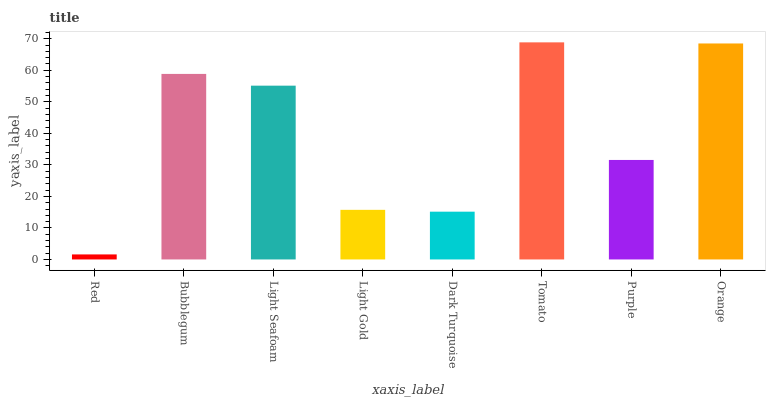Is Bubblegum the minimum?
Answer yes or no. No. Is Bubblegum the maximum?
Answer yes or no. No. Is Bubblegum greater than Red?
Answer yes or no. Yes. Is Red less than Bubblegum?
Answer yes or no. Yes. Is Red greater than Bubblegum?
Answer yes or no. No. Is Bubblegum less than Red?
Answer yes or no. No. Is Light Seafoam the high median?
Answer yes or no. Yes. Is Purple the low median?
Answer yes or no. Yes. Is Purple the high median?
Answer yes or no. No. Is Orange the low median?
Answer yes or no. No. 